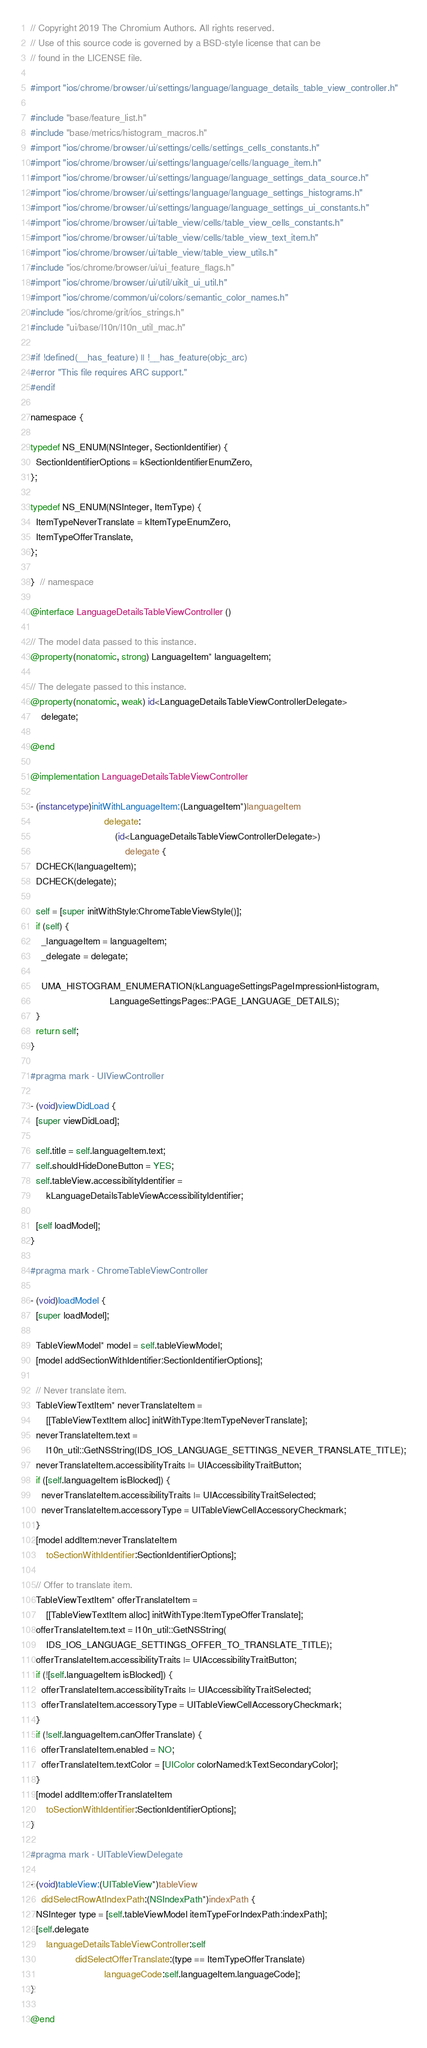Convert code to text. <code><loc_0><loc_0><loc_500><loc_500><_ObjectiveC_>// Copyright 2019 The Chromium Authors. All rights reserved.
// Use of this source code is governed by a BSD-style license that can be
// found in the LICENSE file.

#import "ios/chrome/browser/ui/settings/language/language_details_table_view_controller.h"

#include "base/feature_list.h"
#include "base/metrics/histogram_macros.h"
#import "ios/chrome/browser/ui/settings/cells/settings_cells_constants.h"
#import "ios/chrome/browser/ui/settings/language/cells/language_item.h"
#import "ios/chrome/browser/ui/settings/language/language_settings_data_source.h"
#import "ios/chrome/browser/ui/settings/language/language_settings_histograms.h"
#import "ios/chrome/browser/ui/settings/language/language_settings_ui_constants.h"
#import "ios/chrome/browser/ui/table_view/cells/table_view_cells_constants.h"
#import "ios/chrome/browser/ui/table_view/cells/table_view_text_item.h"
#import "ios/chrome/browser/ui/table_view/table_view_utils.h"
#include "ios/chrome/browser/ui/ui_feature_flags.h"
#import "ios/chrome/browser/ui/util/uikit_ui_util.h"
#import "ios/chrome/common/ui/colors/semantic_color_names.h"
#include "ios/chrome/grit/ios_strings.h"
#include "ui/base/l10n/l10n_util_mac.h"

#if !defined(__has_feature) || !__has_feature(objc_arc)
#error "This file requires ARC support."
#endif

namespace {

typedef NS_ENUM(NSInteger, SectionIdentifier) {
  SectionIdentifierOptions = kSectionIdentifierEnumZero,
};

typedef NS_ENUM(NSInteger, ItemType) {
  ItemTypeNeverTranslate = kItemTypeEnumZero,
  ItemTypeOfferTranslate,
};

}  // namespace

@interface LanguageDetailsTableViewController ()

// The model data passed to this instance.
@property(nonatomic, strong) LanguageItem* languageItem;

// The delegate passed to this instance.
@property(nonatomic, weak) id<LanguageDetailsTableViewControllerDelegate>
    delegate;

@end

@implementation LanguageDetailsTableViewController

- (instancetype)initWithLanguageItem:(LanguageItem*)languageItem
                            delegate:
                                (id<LanguageDetailsTableViewControllerDelegate>)
                                    delegate {
  DCHECK(languageItem);
  DCHECK(delegate);

  self = [super initWithStyle:ChromeTableViewStyle()];
  if (self) {
    _languageItem = languageItem;
    _delegate = delegate;

    UMA_HISTOGRAM_ENUMERATION(kLanguageSettingsPageImpressionHistogram,
                              LanguageSettingsPages::PAGE_LANGUAGE_DETAILS);
  }
  return self;
}

#pragma mark - UIViewController

- (void)viewDidLoad {
  [super viewDidLoad];

  self.title = self.languageItem.text;
  self.shouldHideDoneButton = YES;
  self.tableView.accessibilityIdentifier =
      kLanguageDetailsTableViewAccessibilityIdentifier;

  [self loadModel];
}

#pragma mark - ChromeTableViewController

- (void)loadModel {
  [super loadModel];

  TableViewModel* model = self.tableViewModel;
  [model addSectionWithIdentifier:SectionIdentifierOptions];

  // Never translate item.
  TableViewTextItem* neverTranslateItem =
      [[TableViewTextItem alloc] initWithType:ItemTypeNeverTranslate];
  neverTranslateItem.text =
      l10n_util::GetNSString(IDS_IOS_LANGUAGE_SETTINGS_NEVER_TRANSLATE_TITLE);
  neverTranslateItem.accessibilityTraits |= UIAccessibilityTraitButton;
  if ([self.languageItem isBlocked]) {
    neverTranslateItem.accessibilityTraits |= UIAccessibilityTraitSelected;
    neverTranslateItem.accessoryType = UITableViewCellAccessoryCheckmark;
  }
  [model addItem:neverTranslateItem
      toSectionWithIdentifier:SectionIdentifierOptions];

  // Offer to translate item.
  TableViewTextItem* offerTranslateItem =
      [[TableViewTextItem alloc] initWithType:ItemTypeOfferTranslate];
  offerTranslateItem.text = l10n_util::GetNSString(
      IDS_IOS_LANGUAGE_SETTINGS_OFFER_TO_TRANSLATE_TITLE);
  offerTranslateItem.accessibilityTraits |= UIAccessibilityTraitButton;
  if (![self.languageItem isBlocked]) {
    offerTranslateItem.accessibilityTraits |= UIAccessibilityTraitSelected;
    offerTranslateItem.accessoryType = UITableViewCellAccessoryCheckmark;
  }
  if (!self.languageItem.canOfferTranslate) {
    offerTranslateItem.enabled = NO;
    offerTranslateItem.textColor = [UIColor colorNamed:kTextSecondaryColor];
  }
  [model addItem:offerTranslateItem
      toSectionWithIdentifier:SectionIdentifierOptions];
}

#pragma mark - UITableViewDelegate

- (void)tableView:(UITableView*)tableView
    didSelectRowAtIndexPath:(NSIndexPath*)indexPath {
  NSInteger type = [self.tableViewModel itemTypeForIndexPath:indexPath];
  [self.delegate
      languageDetailsTableViewController:self
                 didSelectOfferTranslate:(type == ItemTypeOfferTranslate)
                            languageCode:self.languageItem.languageCode];
}

@end
</code> 